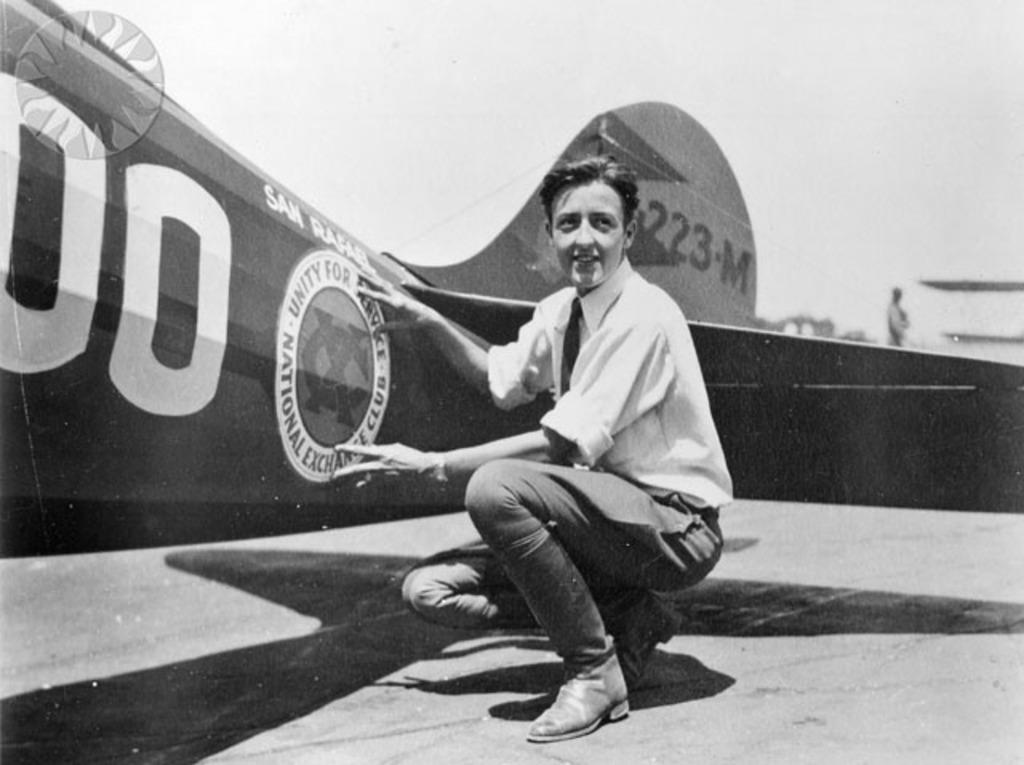What is the person in the image doing? There is a person sitting in the image, and they are touching an airplane. Can you describe the setting of the image? The person is sitting in front of an airplane, and there appears to be another person at the back of the image. The sky is also visible in the image. What might the person touching the airplane be doing? The person touching the airplane might be inspecting it, boarding it, or simply interacting with it. How much payment is required to access the ear of the airplane in the image? There is no ear present on the airplane in the image, and payment is not mentioned or implied in the provided facts. 